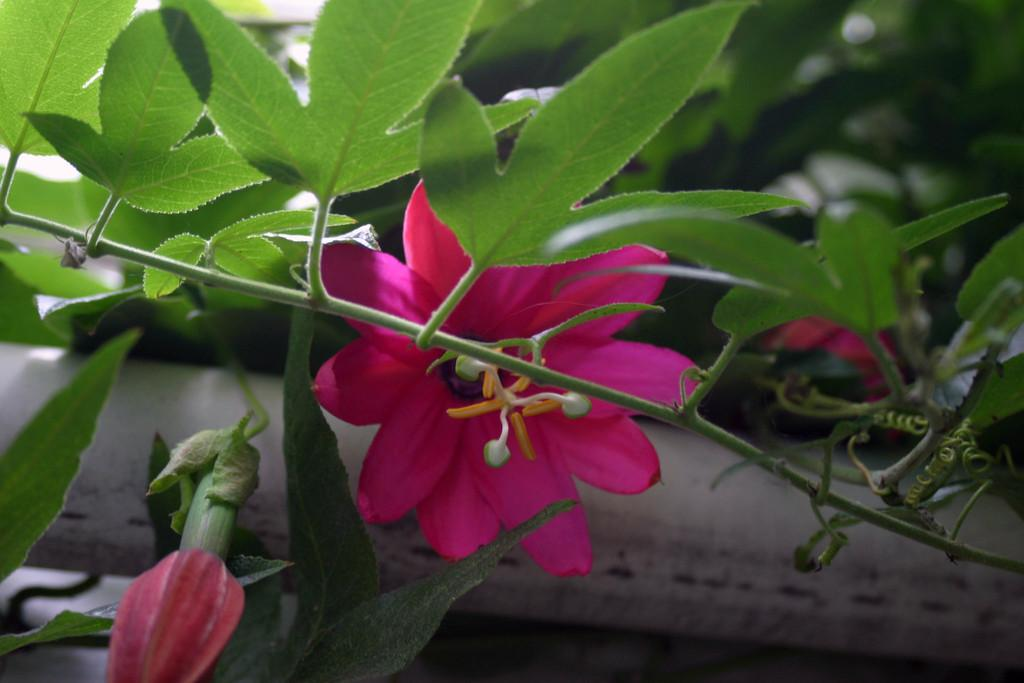What is present in the image? There is a plant in the image. What specific features does the plant have? The plant has a flower and a bud. What color is the flower on the plant? The flower is pink in color. Can you see a dog giving a kiss to someone in the image? There is no dog or person present in the image, so it is not a kiss cannot be observed. 